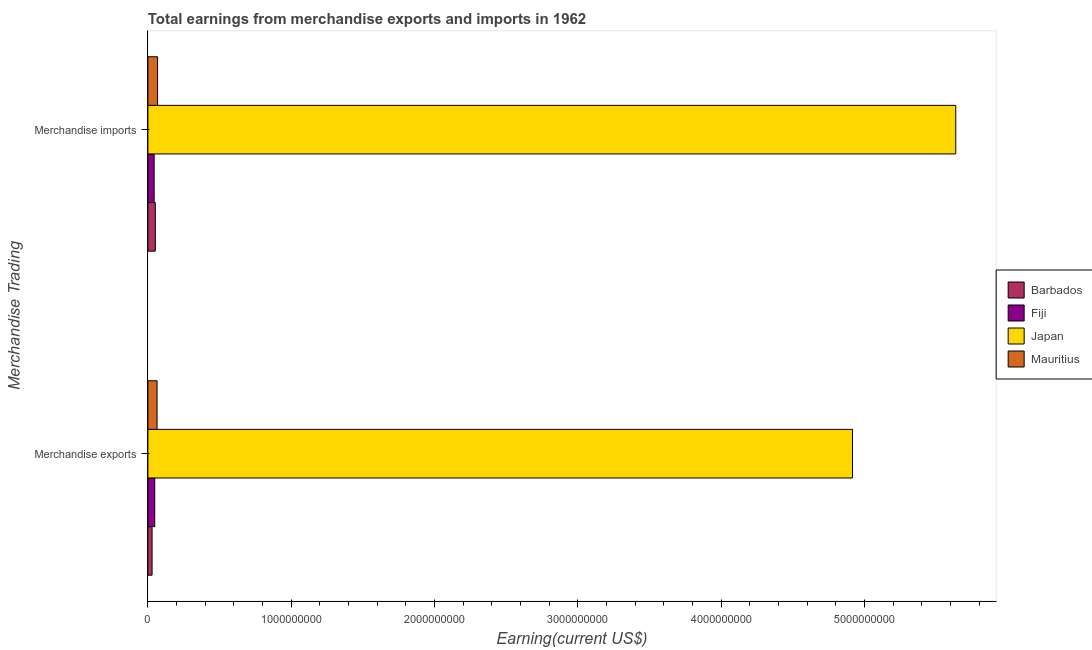How many bars are there on the 2nd tick from the bottom?
Your answer should be compact. 4. What is the label of the 1st group of bars from the top?
Provide a short and direct response. Merchandise imports. What is the earnings from merchandise exports in Mauritius?
Give a very brief answer. 6.42e+07. Across all countries, what is the maximum earnings from merchandise imports?
Your response must be concise. 5.64e+09. Across all countries, what is the minimum earnings from merchandise imports?
Offer a very short reply. 4.39e+07. In which country was the earnings from merchandise exports minimum?
Your answer should be compact. Barbados. What is the total earnings from merchandise imports in the graph?
Provide a short and direct response. 5.80e+09. What is the difference between the earnings from merchandise imports in Mauritius and that in Fiji?
Keep it short and to the point. 2.39e+07. What is the difference between the earnings from merchandise imports in Barbados and the earnings from merchandise exports in Fiji?
Offer a terse response. 4.05e+06. What is the average earnings from merchandise imports per country?
Provide a succinct answer. 1.45e+09. What is the difference between the earnings from merchandise exports and earnings from merchandise imports in Japan?
Offer a very short reply. -7.20e+08. In how many countries, is the earnings from merchandise imports greater than 600000000 US$?
Provide a short and direct response. 1. What is the ratio of the earnings from merchandise imports in Japan to that in Barbados?
Keep it short and to the point. 108.45. What does the 1st bar from the top in Merchandise exports represents?
Provide a succinct answer. Mauritius. What does the 2nd bar from the bottom in Merchandise exports represents?
Provide a succinct answer. Fiji. How many bars are there?
Your answer should be compact. 8. Are all the bars in the graph horizontal?
Provide a succinct answer. Yes. Where does the legend appear in the graph?
Provide a succinct answer. Center right. How many legend labels are there?
Give a very brief answer. 4. What is the title of the graph?
Keep it short and to the point. Total earnings from merchandise exports and imports in 1962. What is the label or title of the X-axis?
Make the answer very short. Earning(current US$). What is the label or title of the Y-axis?
Offer a terse response. Merchandise Trading. What is the Earning(current US$) of Barbados in Merchandise exports?
Keep it short and to the point. 2.93e+07. What is the Earning(current US$) of Fiji in Merchandise exports?
Offer a terse response. 4.79e+07. What is the Earning(current US$) in Japan in Merchandise exports?
Your answer should be compact. 4.92e+09. What is the Earning(current US$) of Mauritius in Merchandise exports?
Offer a terse response. 6.42e+07. What is the Earning(current US$) in Barbados in Merchandise imports?
Offer a very short reply. 5.20e+07. What is the Earning(current US$) of Fiji in Merchandise imports?
Provide a succinct answer. 4.39e+07. What is the Earning(current US$) of Japan in Merchandise imports?
Your answer should be compact. 5.64e+09. What is the Earning(current US$) in Mauritius in Merchandise imports?
Offer a terse response. 6.78e+07. Across all Merchandise Trading, what is the maximum Earning(current US$) in Barbados?
Make the answer very short. 5.20e+07. Across all Merchandise Trading, what is the maximum Earning(current US$) of Fiji?
Offer a terse response. 4.79e+07. Across all Merchandise Trading, what is the maximum Earning(current US$) in Japan?
Provide a succinct answer. 5.64e+09. Across all Merchandise Trading, what is the maximum Earning(current US$) in Mauritius?
Your answer should be compact. 6.78e+07. Across all Merchandise Trading, what is the minimum Earning(current US$) of Barbados?
Offer a very short reply. 2.93e+07. Across all Merchandise Trading, what is the minimum Earning(current US$) in Fiji?
Make the answer very short. 4.39e+07. Across all Merchandise Trading, what is the minimum Earning(current US$) of Japan?
Offer a very short reply. 4.92e+09. Across all Merchandise Trading, what is the minimum Earning(current US$) in Mauritius?
Your answer should be compact. 6.42e+07. What is the total Earning(current US$) in Barbados in the graph?
Give a very brief answer. 8.13e+07. What is the total Earning(current US$) in Fiji in the graph?
Keep it short and to the point. 9.18e+07. What is the total Earning(current US$) in Japan in the graph?
Offer a terse response. 1.06e+1. What is the total Earning(current US$) of Mauritius in the graph?
Offer a very short reply. 1.32e+08. What is the difference between the Earning(current US$) of Barbados in Merchandise exports and that in Merchandise imports?
Offer a terse response. -2.26e+07. What is the difference between the Earning(current US$) in Fiji in Merchandise exports and that in Merchandise imports?
Your answer should be very brief. 4.07e+06. What is the difference between the Earning(current US$) of Japan in Merchandise exports and that in Merchandise imports?
Your answer should be compact. -7.20e+08. What is the difference between the Earning(current US$) of Mauritius in Merchandise exports and that in Merchandise imports?
Keep it short and to the point. -3.53e+06. What is the difference between the Earning(current US$) in Barbados in Merchandise exports and the Earning(current US$) in Fiji in Merchandise imports?
Provide a short and direct response. -1.45e+07. What is the difference between the Earning(current US$) of Barbados in Merchandise exports and the Earning(current US$) of Japan in Merchandise imports?
Ensure brevity in your answer.  -5.61e+09. What is the difference between the Earning(current US$) in Barbados in Merchandise exports and the Earning(current US$) in Mauritius in Merchandise imports?
Make the answer very short. -3.84e+07. What is the difference between the Earning(current US$) in Fiji in Merchandise exports and the Earning(current US$) in Japan in Merchandise imports?
Provide a short and direct response. -5.59e+09. What is the difference between the Earning(current US$) in Fiji in Merchandise exports and the Earning(current US$) in Mauritius in Merchandise imports?
Your answer should be very brief. -1.98e+07. What is the difference between the Earning(current US$) of Japan in Merchandise exports and the Earning(current US$) of Mauritius in Merchandise imports?
Ensure brevity in your answer.  4.85e+09. What is the average Earning(current US$) in Barbados per Merchandise Trading?
Your answer should be very brief. 4.07e+07. What is the average Earning(current US$) of Fiji per Merchandise Trading?
Your answer should be very brief. 4.59e+07. What is the average Earning(current US$) of Japan per Merchandise Trading?
Offer a very short reply. 5.28e+09. What is the average Earning(current US$) of Mauritius per Merchandise Trading?
Ensure brevity in your answer.  6.60e+07. What is the difference between the Earning(current US$) in Barbados and Earning(current US$) in Fiji in Merchandise exports?
Offer a terse response. -1.86e+07. What is the difference between the Earning(current US$) of Barbados and Earning(current US$) of Japan in Merchandise exports?
Your response must be concise. -4.89e+09. What is the difference between the Earning(current US$) of Barbados and Earning(current US$) of Mauritius in Merchandise exports?
Offer a very short reply. -3.49e+07. What is the difference between the Earning(current US$) in Fiji and Earning(current US$) in Japan in Merchandise exports?
Your answer should be very brief. -4.87e+09. What is the difference between the Earning(current US$) of Fiji and Earning(current US$) of Mauritius in Merchandise exports?
Your answer should be compact. -1.63e+07. What is the difference between the Earning(current US$) in Japan and Earning(current US$) in Mauritius in Merchandise exports?
Make the answer very short. 4.85e+09. What is the difference between the Earning(current US$) in Barbados and Earning(current US$) in Fiji in Merchandise imports?
Your answer should be very brief. 8.12e+06. What is the difference between the Earning(current US$) in Barbados and Earning(current US$) in Japan in Merchandise imports?
Make the answer very short. -5.58e+09. What is the difference between the Earning(current US$) in Barbados and Earning(current US$) in Mauritius in Merchandise imports?
Your response must be concise. -1.58e+07. What is the difference between the Earning(current US$) in Fiji and Earning(current US$) in Japan in Merchandise imports?
Give a very brief answer. -5.59e+09. What is the difference between the Earning(current US$) in Fiji and Earning(current US$) in Mauritius in Merchandise imports?
Ensure brevity in your answer.  -2.39e+07. What is the difference between the Earning(current US$) in Japan and Earning(current US$) in Mauritius in Merchandise imports?
Provide a short and direct response. 5.57e+09. What is the ratio of the Earning(current US$) in Barbados in Merchandise exports to that in Merchandise imports?
Offer a very short reply. 0.56. What is the ratio of the Earning(current US$) of Fiji in Merchandise exports to that in Merchandise imports?
Offer a terse response. 1.09. What is the ratio of the Earning(current US$) in Japan in Merchandise exports to that in Merchandise imports?
Offer a very short reply. 0.87. What is the ratio of the Earning(current US$) of Mauritius in Merchandise exports to that in Merchandise imports?
Your response must be concise. 0.95. What is the difference between the highest and the second highest Earning(current US$) in Barbados?
Offer a terse response. 2.26e+07. What is the difference between the highest and the second highest Earning(current US$) of Fiji?
Provide a succinct answer. 4.07e+06. What is the difference between the highest and the second highest Earning(current US$) in Japan?
Keep it short and to the point. 7.20e+08. What is the difference between the highest and the second highest Earning(current US$) of Mauritius?
Ensure brevity in your answer.  3.53e+06. What is the difference between the highest and the lowest Earning(current US$) of Barbados?
Provide a short and direct response. 2.26e+07. What is the difference between the highest and the lowest Earning(current US$) of Fiji?
Your answer should be very brief. 4.07e+06. What is the difference between the highest and the lowest Earning(current US$) in Japan?
Your answer should be very brief. 7.20e+08. What is the difference between the highest and the lowest Earning(current US$) of Mauritius?
Your answer should be compact. 3.53e+06. 